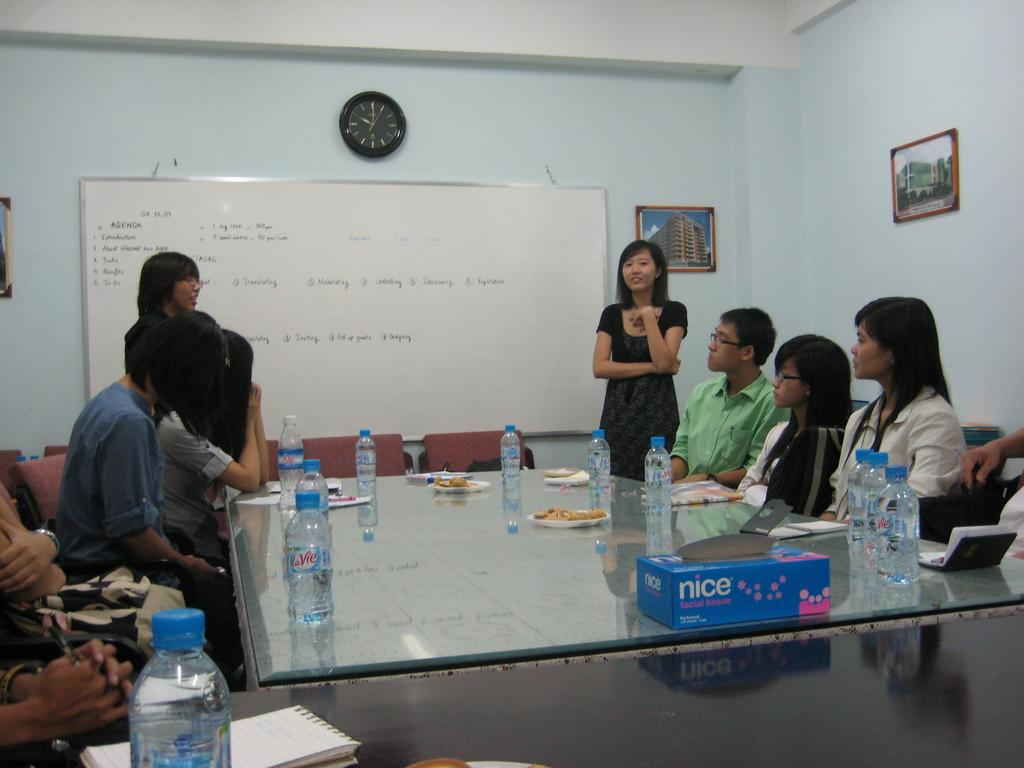<image>
Render a clear and concise summary of the photo. Several people are having a meeting in a board room and have bottles of LaVie water in front of them. 